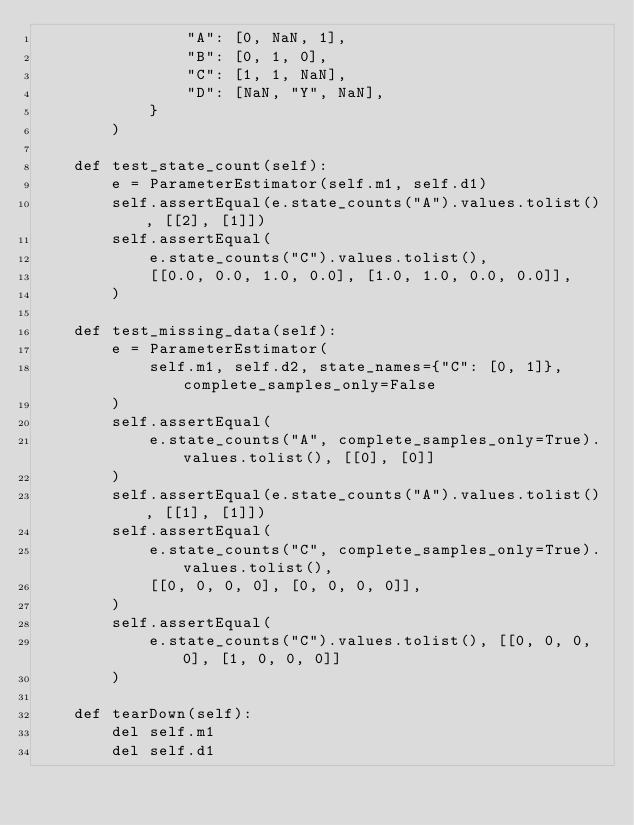Convert code to text. <code><loc_0><loc_0><loc_500><loc_500><_Python_>                "A": [0, NaN, 1],
                "B": [0, 1, 0],
                "C": [1, 1, NaN],
                "D": [NaN, "Y", NaN],
            }
        )

    def test_state_count(self):
        e = ParameterEstimator(self.m1, self.d1)
        self.assertEqual(e.state_counts("A").values.tolist(), [[2], [1]])
        self.assertEqual(
            e.state_counts("C").values.tolist(),
            [[0.0, 0.0, 1.0, 0.0], [1.0, 1.0, 0.0, 0.0]],
        )

    def test_missing_data(self):
        e = ParameterEstimator(
            self.m1, self.d2, state_names={"C": [0, 1]}, complete_samples_only=False
        )
        self.assertEqual(
            e.state_counts("A", complete_samples_only=True).values.tolist(), [[0], [0]]
        )
        self.assertEqual(e.state_counts("A").values.tolist(), [[1], [1]])
        self.assertEqual(
            e.state_counts("C", complete_samples_only=True).values.tolist(),
            [[0, 0, 0, 0], [0, 0, 0, 0]],
        )
        self.assertEqual(
            e.state_counts("C").values.tolist(), [[0, 0, 0, 0], [1, 0, 0, 0]]
        )

    def tearDown(self):
        del self.m1
        del self.d1
</code> 